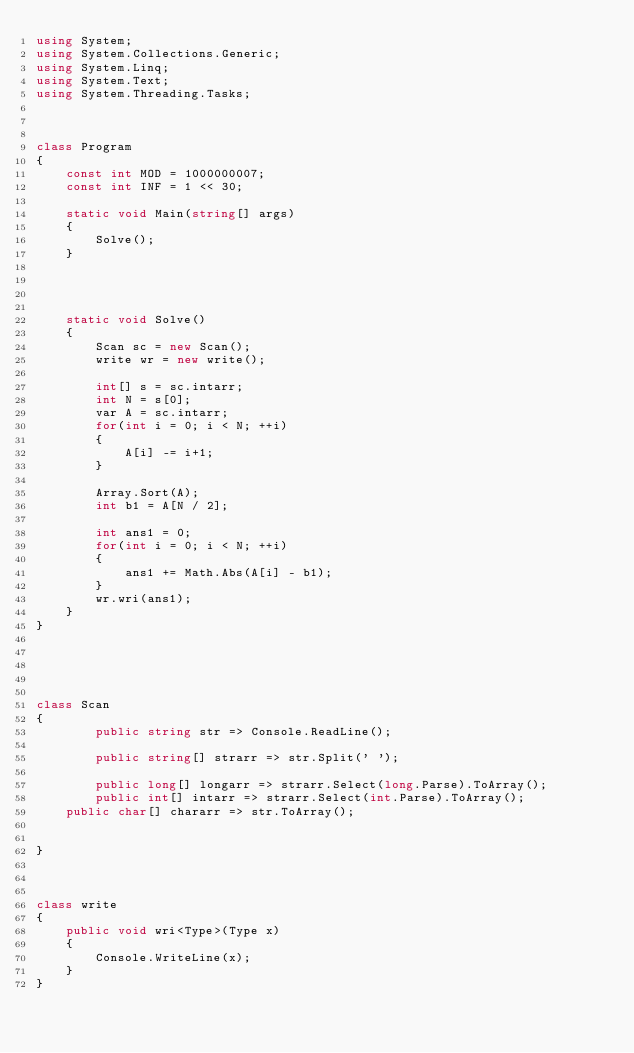<code> <loc_0><loc_0><loc_500><loc_500><_C#_>using System;
using System.Collections.Generic;
using System.Linq;
using System.Text;
using System.Threading.Tasks;



class Program
{
    const int MOD = 1000000007;
    const int INF = 1 << 30;

    static void Main(string[] args)
    {
        Solve();
    }




    static void Solve()
    {
        Scan sc = new Scan();
        write wr = new write();

        int[] s = sc.intarr;
        int N = s[0];
        var A = sc.intarr;
        for(int i = 0; i < N; ++i)
        {
            A[i] -= i+1;
        }

        Array.Sort(A);
        int b1 = A[N / 2];

        int ans1 = 0;
        for(int i = 0; i < N; ++i)
        {
            ans1 += Math.Abs(A[i] - b1);
        }
        wr.wri(ans1);
    }
}
    




class Scan
{
        public string str => Console.ReadLine();

        public string[] strarr => str.Split(' ');

        public long[] longarr => strarr.Select(long.Parse).ToArray();
        public int[] intarr => strarr.Select(int.Parse).ToArray();
    public char[] chararr => str.ToArray();


}



class write
{
    public void wri<Type>(Type x)
    {
        Console.WriteLine(x);
    }
}
</code> 